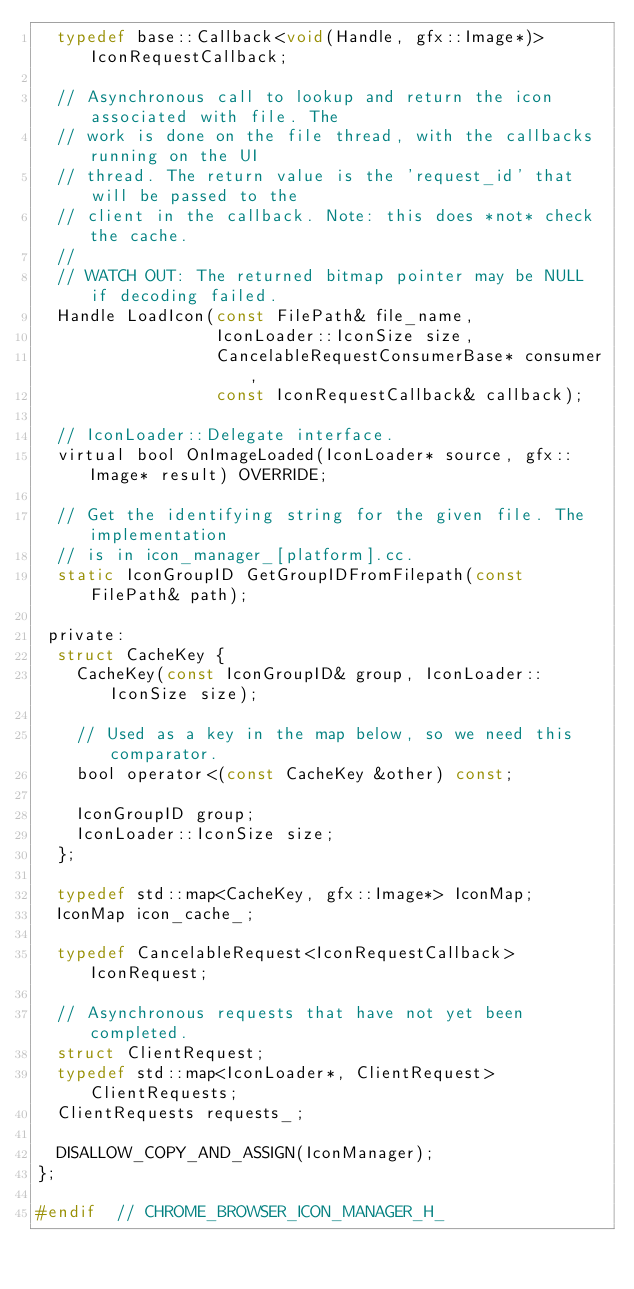<code> <loc_0><loc_0><loc_500><loc_500><_C_>  typedef base::Callback<void(Handle, gfx::Image*)> IconRequestCallback;

  // Asynchronous call to lookup and return the icon associated with file. The
  // work is done on the file thread, with the callbacks running on the UI
  // thread. The return value is the 'request_id' that will be passed to the
  // client in the callback. Note: this does *not* check the cache.
  //
  // WATCH OUT: The returned bitmap pointer may be NULL if decoding failed.
  Handle LoadIcon(const FilePath& file_name,
                  IconLoader::IconSize size,
                  CancelableRequestConsumerBase* consumer,
                  const IconRequestCallback& callback);

  // IconLoader::Delegate interface.
  virtual bool OnImageLoaded(IconLoader* source, gfx::Image* result) OVERRIDE;

  // Get the identifying string for the given file. The implementation
  // is in icon_manager_[platform].cc.
  static IconGroupID GetGroupIDFromFilepath(const FilePath& path);

 private:
  struct CacheKey {
    CacheKey(const IconGroupID& group, IconLoader::IconSize size);

    // Used as a key in the map below, so we need this comparator.
    bool operator<(const CacheKey &other) const;

    IconGroupID group;
    IconLoader::IconSize size;
  };

  typedef std::map<CacheKey, gfx::Image*> IconMap;
  IconMap icon_cache_;

  typedef CancelableRequest<IconRequestCallback> IconRequest;

  // Asynchronous requests that have not yet been completed.
  struct ClientRequest;
  typedef std::map<IconLoader*, ClientRequest> ClientRequests;
  ClientRequests requests_;

  DISALLOW_COPY_AND_ASSIGN(IconManager);
};

#endif  // CHROME_BROWSER_ICON_MANAGER_H_
</code> 